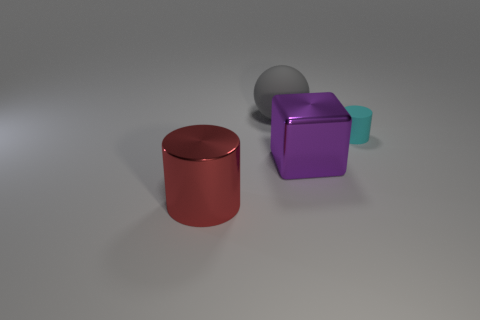There is a cylinder behind the big metallic object behind the red metallic cylinder; what is it made of?
Provide a short and direct response. Rubber. Is the number of purple metallic blocks that are behind the big purple block greater than the number of balls?
Give a very brief answer. No. How many other things are there of the same size as the red shiny cylinder?
Your response must be concise. 2. Is the big matte ball the same color as the large cylinder?
Provide a succinct answer. No. There is a cylinder in front of the big metal object that is right of the cylinder that is in front of the metal cube; what is its color?
Your response must be concise. Red. How many purple blocks are behind the object behind the rubber thing to the right of the sphere?
Your answer should be very brief. 0. Are there any other things of the same color as the large cube?
Provide a succinct answer. No. There is a metallic object that is to the left of the shiny cube; does it have the same size as the small thing?
Provide a succinct answer. No. How many large things are on the left side of the object that is behind the tiny cyan rubber cylinder?
Make the answer very short. 1. There is a cylinder on the right side of the gray sphere that is behind the matte cylinder; are there any rubber things to the left of it?
Offer a terse response. Yes. 